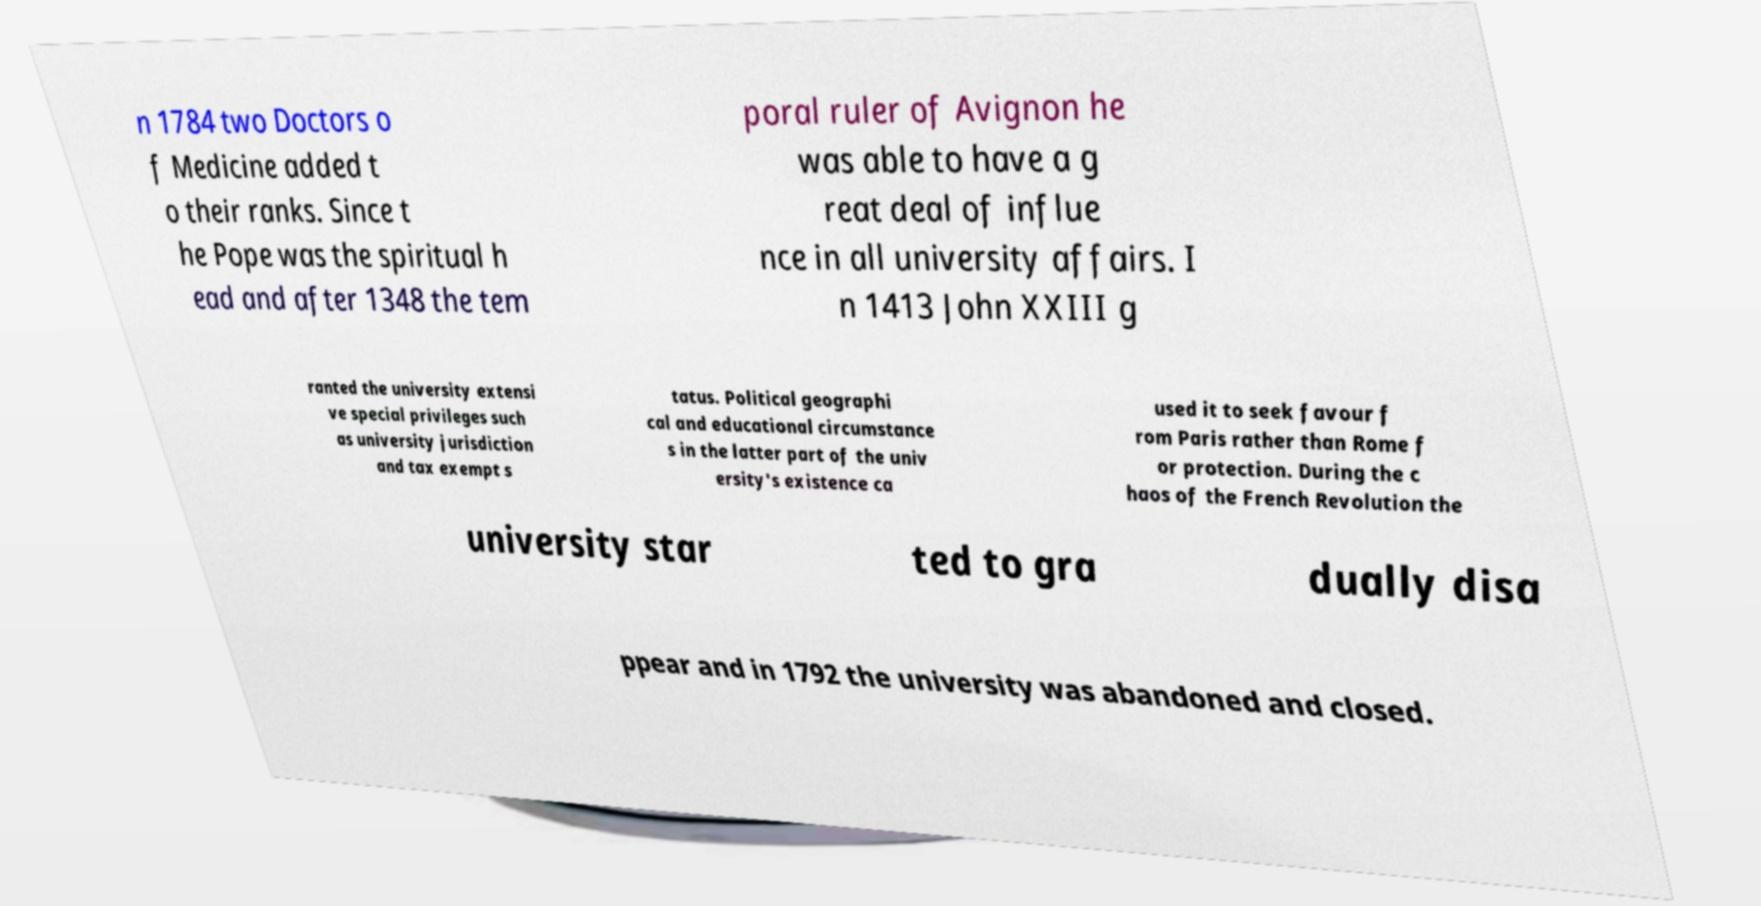What messages or text are displayed in this image? I need them in a readable, typed format. n 1784 two Doctors o f Medicine added t o their ranks. Since t he Pope was the spiritual h ead and after 1348 the tem poral ruler of Avignon he was able to have a g reat deal of influe nce in all university affairs. I n 1413 John XXIII g ranted the university extensi ve special privileges such as university jurisdiction and tax exempt s tatus. Political geographi cal and educational circumstance s in the latter part of the univ ersity's existence ca used it to seek favour f rom Paris rather than Rome f or protection. During the c haos of the French Revolution the university star ted to gra dually disa ppear and in 1792 the university was abandoned and closed. 